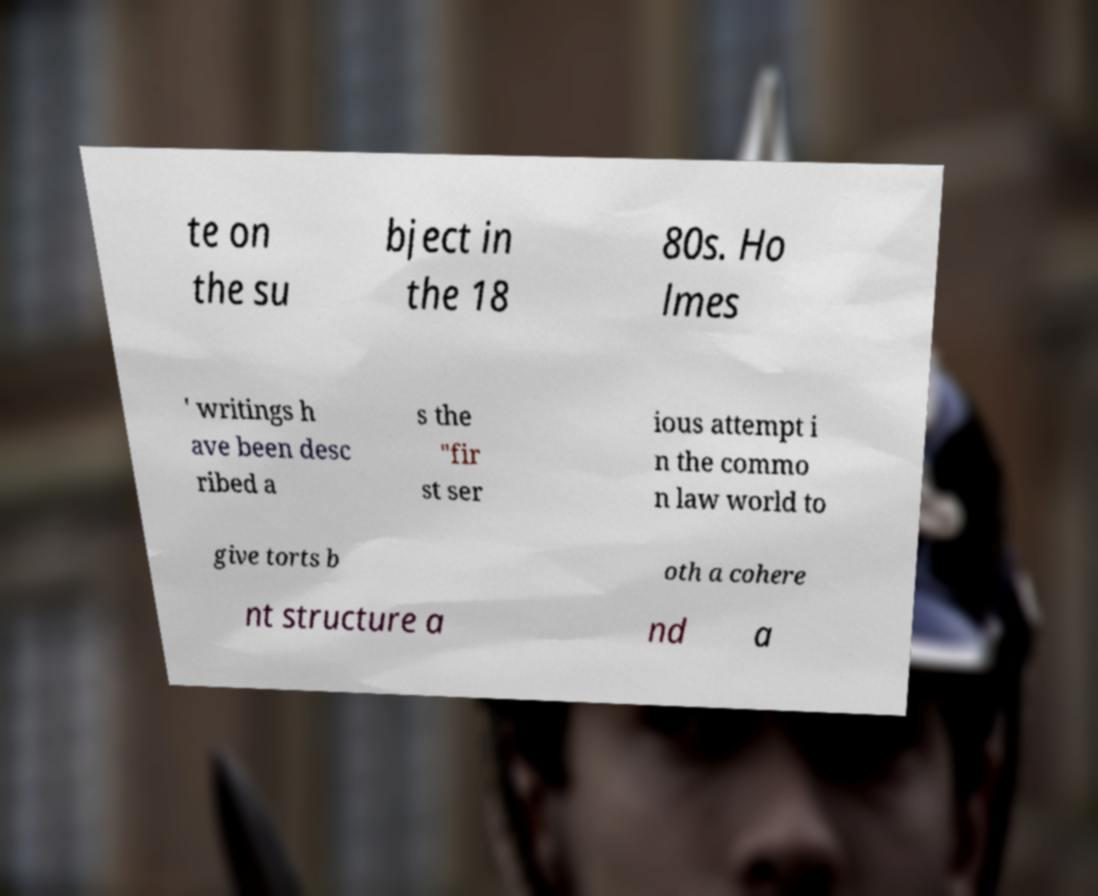I need the written content from this picture converted into text. Can you do that? te on the su bject in the 18 80s. Ho lmes ' writings h ave been desc ribed a s the "fir st ser ious attempt i n the commo n law world to give torts b oth a cohere nt structure a nd a 